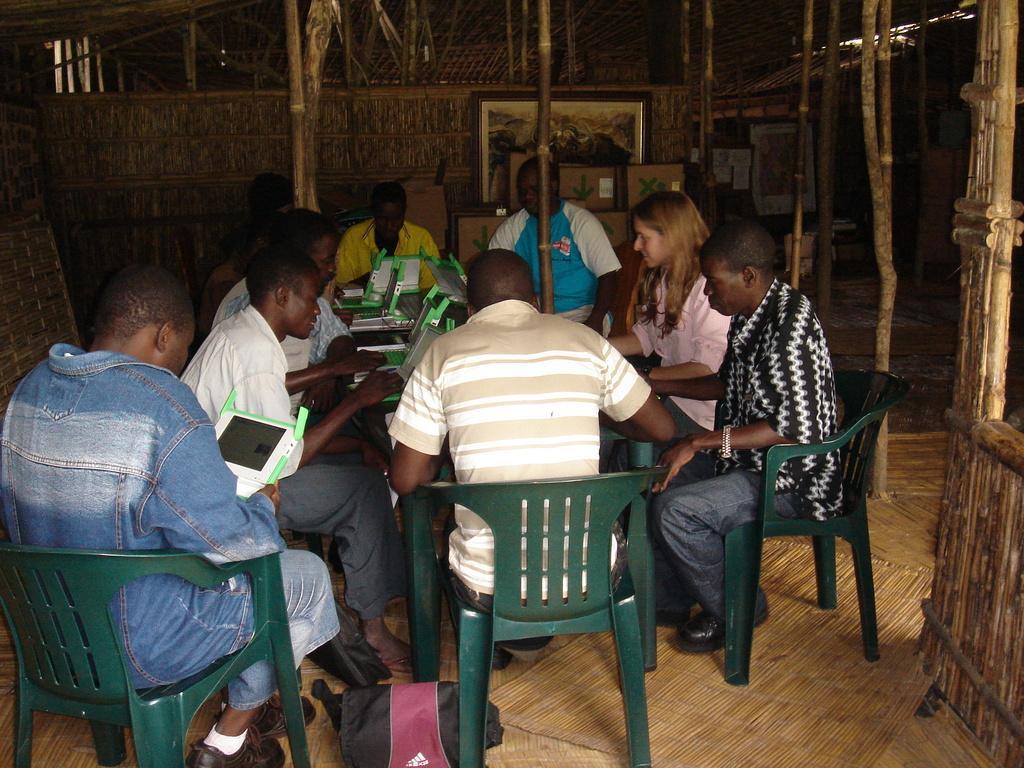In one or two sentences, can you explain what this image depicts? A group of people are sitting on the chair and few are holding laptops in their hands. We can see pole,frame,cotton boxes and a bag in this room and there is also a table between them. 